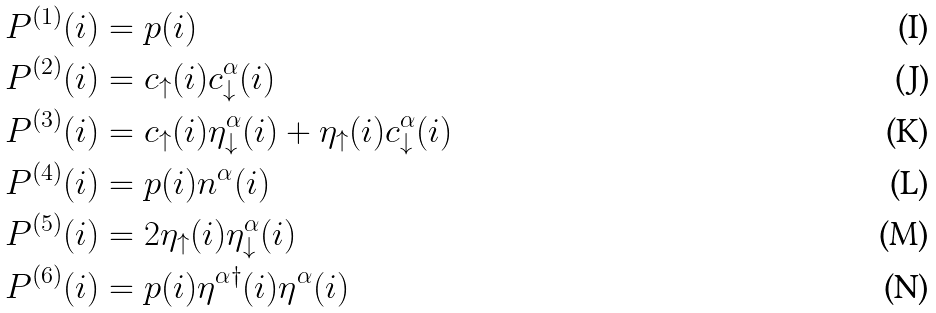<formula> <loc_0><loc_0><loc_500><loc_500>P ^ { ( 1 ) } ( i ) & = p ( i ) \\ P ^ { ( 2 ) } ( i ) & = c _ { \uparrow } ( i ) c _ { \downarrow } ^ { \alpha } ( i ) \\ P ^ { ( 3 ) } ( i ) & = c _ { \uparrow } ( i ) \eta _ { \downarrow } ^ { \alpha } ( i ) + \eta _ { \uparrow } ( i ) c _ { \downarrow } ^ { \alpha } ( i ) \\ P ^ { ( 4 ) } ( i ) & = p ( i ) n ^ { \alpha } ( i ) \\ P ^ { ( 5 ) } ( i ) & = 2 \eta _ { \uparrow } ( i ) \eta _ { \downarrow } ^ { \alpha } ( i ) \\ P ^ { ( 6 ) } ( i ) & = p ( i ) \eta ^ { \alpha \dagger } ( i ) \eta ^ { \alpha } ( i )</formula> 